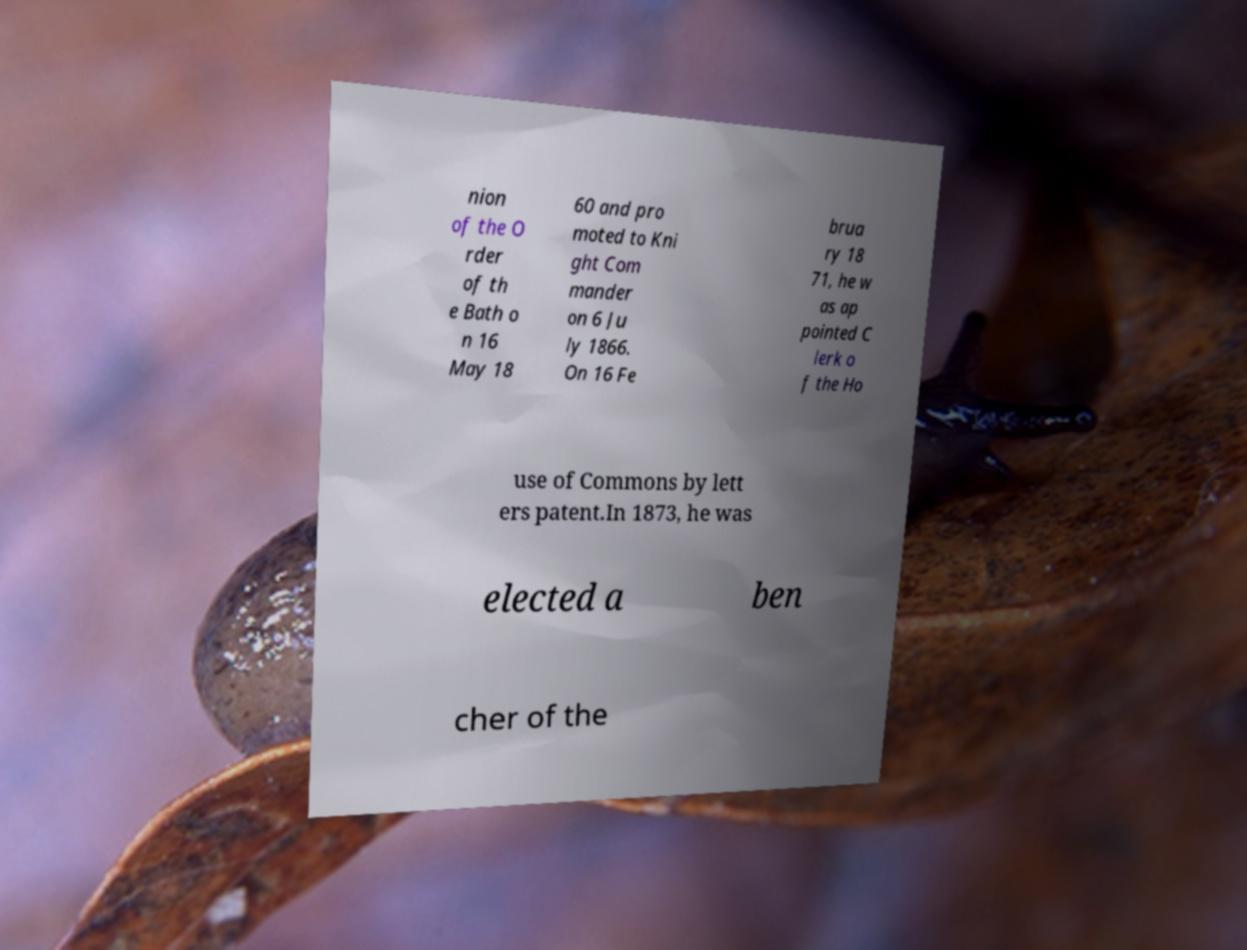Could you extract and type out the text from this image? nion of the O rder of th e Bath o n 16 May 18 60 and pro moted to Kni ght Com mander on 6 Ju ly 1866. On 16 Fe brua ry 18 71, he w as ap pointed C lerk o f the Ho use of Commons by lett ers patent.In 1873, he was elected a ben cher of the 